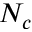Convert formula to latex. <formula><loc_0><loc_0><loc_500><loc_500>N _ { c }</formula> 